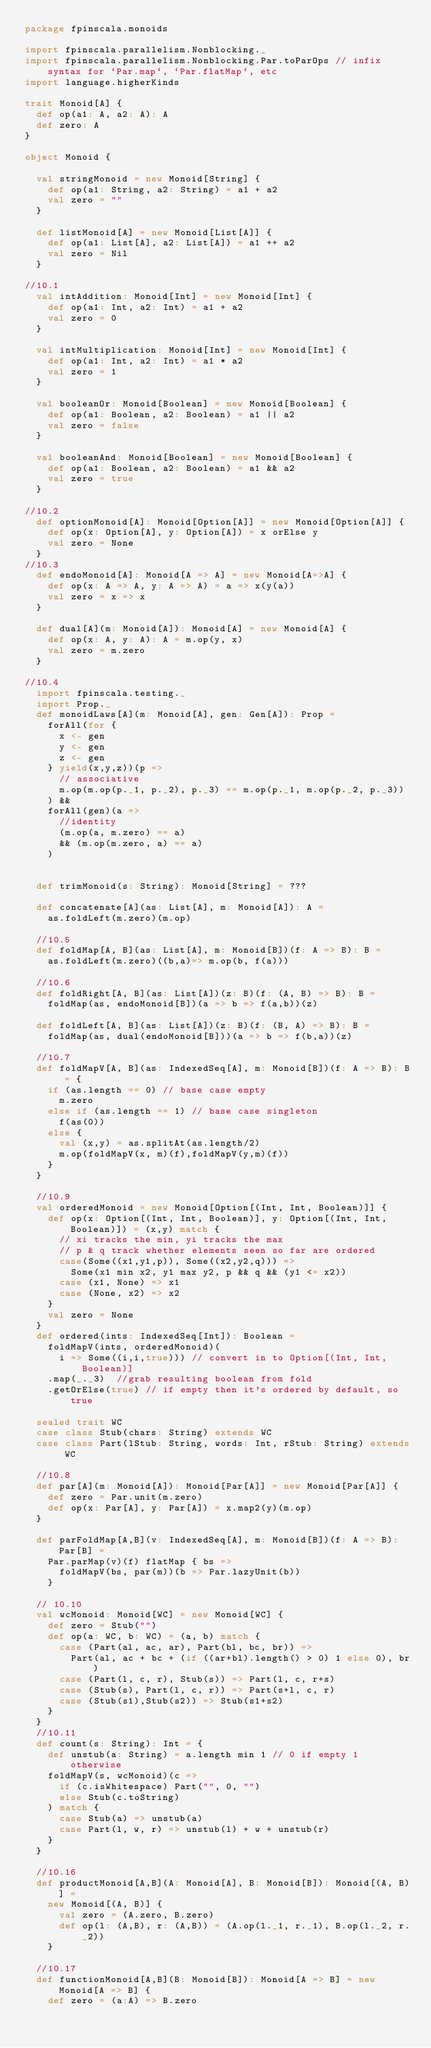<code> <loc_0><loc_0><loc_500><loc_500><_Scala_>package fpinscala.monoids

import fpinscala.parallelism.Nonblocking._
import fpinscala.parallelism.Nonblocking.Par.toParOps // infix syntax for `Par.map`, `Par.flatMap`, etc
import language.higherKinds

trait Monoid[A] {
  def op(a1: A, a2: A): A
  def zero: A
}

object Monoid {

  val stringMonoid = new Monoid[String] {
    def op(a1: String, a2: String) = a1 + a2
    val zero = ""
  }

  def listMonoid[A] = new Monoid[List[A]] {
    def op(a1: List[A], a2: List[A]) = a1 ++ a2
    val zero = Nil
  }

//10.1
  val intAddition: Monoid[Int] = new Monoid[Int] {
    def op(a1: Int, a2: Int) = a1 + a2
    val zero = 0
  }

  val intMultiplication: Monoid[Int] = new Monoid[Int] {
    def op(a1: Int, a2: Int) = a1 * a2
    val zero = 1
  }

  val booleanOr: Monoid[Boolean] = new Monoid[Boolean] {
    def op(a1: Boolean, a2: Boolean) = a1 || a2
    val zero = false
  }

  val booleanAnd: Monoid[Boolean] = new Monoid[Boolean] {
    def op(a1: Boolean, a2: Boolean) = a1 && a2
    val zero = true
  }

//10.2
  def optionMonoid[A]: Monoid[Option[A]] = new Monoid[Option[A]] {
    def op(x: Option[A], y: Option[A]) = x orElse y
    val zero = None
  }
//10.3
  def endoMonoid[A]: Monoid[A => A] = new Monoid[A=>A] {
    def op(x: A => A, y: A => A) = a => x(y(a))
    val zero = x => x
  }

  def dual[A](m: Monoid[A]): Monoid[A] = new Monoid[A] {
    def op(x: A, y: A): A = m.op(y, x)
    val zero = m.zero
  }

//10.4
  import fpinscala.testing._
  import Prop._
  def monoidLaws[A](m: Monoid[A], gen: Gen[A]): Prop = 
    forAll(for {
      x <- gen
      y <- gen
      z <- gen
    } yield(x,y,z))(p =>
      // associative
      m.op(m.op(p._1, p._2), p._3) == m.op(p._1, m.op(p._2, p._3))
    ) && 
    forAll(gen)(a =>
      //identity
      (m.op(a, m.zero) == a)
      && (m.op(m.zero, a) == a)
    )


  def trimMonoid(s: String): Monoid[String] = ???

  def concatenate[A](as: List[A], m: Monoid[A]): A =
    as.foldLeft(m.zero)(m.op)

  //10.5
  def foldMap[A, B](as: List[A], m: Monoid[B])(f: A => B): B =
    as.foldLeft(m.zero)((b,a)=> m.op(b, f(a)))

  //10.6
  def foldRight[A, B](as: List[A])(z: B)(f: (A, B) => B): B =
    foldMap(as, endoMonoid[B])(a => b => f(a,b))(z)

  def foldLeft[A, B](as: List[A])(z: B)(f: (B, A) => B): B =
    foldMap(as, dual(endoMonoid[B]))(a => b => f(b,a))(z)

  //10.7
  def foldMapV[A, B](as: IndexedSeq[A], m: Monoid[B])(f: A => B): B = {
    if (as.length == 0) // base case empty
      m.zero
    else if (as.length == 1) // base case singleton
      f(as(0))
    else {
      val (x,y) = as.splitAt(as.length/2)
      m.op(foldMapV(x, m)(f),foldMapV(y,m)(f))
    }
  }

  //10.9
  val orderedMonoid = new Monoid[Option[(Int, Int, Boolean)]] {
    def op(x: Option[(Int, Int, Boolean)], y: Option[(Int, Int, Boolean)]) = (x,y) match {
      // xi tracks the min, yi tracks the max
      // p & q track whether elements seen so far are ordered
      case(Some((x1,y1,p)), Some((x2,y2,q))) =>
        Some(x1 min x2, y1 max y2, p && q && (y1 <= x2))
      case (x1, None) => x1
      case (None, x2) => x2
    }
    val zero = None
  }
  def ordered(ints: IndexedSeq[Int]): Boolean =
    foldMapV(ints, orderedMonoid)(
      i => Some((i,i,true))) // convert in to Option[(Int, Int, Boolean)]
    .map(_._3)  //grab resulting boolean from fold
    .getOrElse(true) // if empty then it's ordered by default, so true

  sealed trait WC
  case class Stub(chars: String) extends WC
  case class Part(lStub: String, words: Int, rStub: String) extends WC

  //10.8
  def par[A](m: Monoid[A]): Monoid[Par[A]] = new Monoid[Par[A]] {
    def zero = Par.unit(m.zero)
    def op(x: Par[A], y: Par[A]) = x.map2(y)(m.op)
  }

  def parFoldMap[A,B](v: IndexedSeq[A], m: Monoid[B])(f: A => B): Par[B] = 
    Par.parMap(v)(f) flatMap { bs =>
      foldMapV(bs, par(m))(b => Par.lazyUnit(b))
    }

  // 10.10
  val wcMonoid: Monoid[WC] = new Monoid[WC] {
    def zero = Stub("")
    def op(a: WC, b: WC) = (a, b) match {
      case (Part(al, ac, ar), Part(bl, bc, br)) => 
        Part(al, ac + bc + (if ((ar+bl).length() > 0) 1 else 0), br)
      case (Part(l, c, r), Stub(s)) => Part(l, c, r+s)
      case (Stub(s), Part(l, c, r)) => Part(s+l, c, r)
      case (Stub(s1),Stub(s2)) => Stub(s1+s2)
    }
  }
  //10.11
  def count(s: String): Int = {
    def unstub(a: String) = a.length min 1 // 0 if empty 1 otherwise
    foldMapV(s, wcMonoid)(c => 
      if (c.isWhitespace) Part("", 0, "") 
      else Stub(c.toString)
    ) match {
      case Stub(a) => unstub(a)
      case Part(l, w, r) => unstub(l) + w + unstub(r)
    }
  }
    
  //10.16
  def productMonoid[A,B](A: Monoid[A], B: Monoid[B]): Monoid[(A, B)] = 
    new Monoid[(A, B)] {
      val zero = (A.zero, B.zero)
      def op(l: (A,B), r: (A,B)) = (A.op(l._1, r._1), B.op(l._2, r._2))
    }
    
  //10.17
  def functionMonoid[A,B](B: Monoid[B]): Monoid[A => B] = new Monoid[A => B] {
    def zero = (a:A) => B.zero</code> 